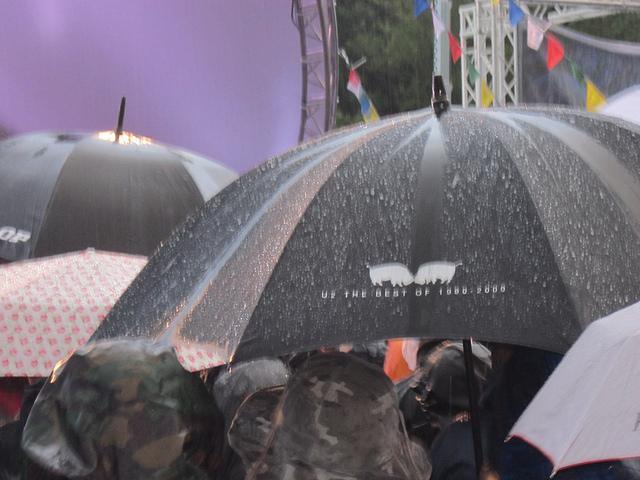How many people can you see?
Give a very brief answer. 5. How many umbrellas are visible?
Give a very brief answer. 4. 